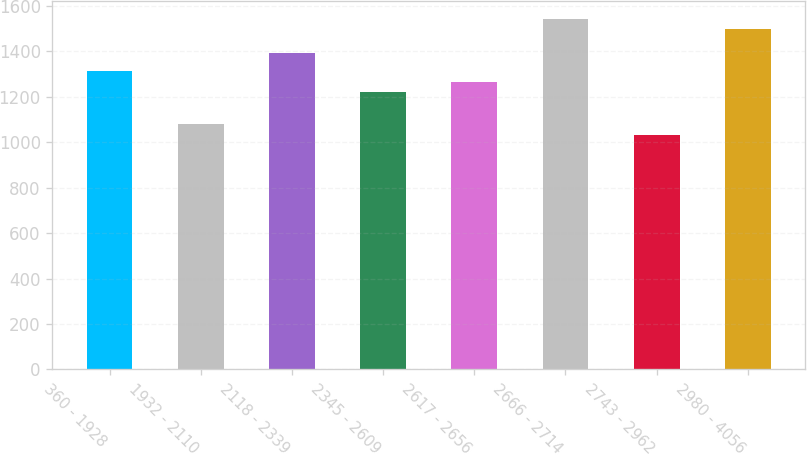Convert chart. <chart><loc_0><loc_0><loc_500><loc_500><bar_chart><fcel>360 - 1928<fcel>1932 - 2110<fcel>2118 - 2339<fcel>2345 - 2609<fcel>2617 - 2656<fcel>2666 - 2714<fcel>2743 - 2962<fcel>2980 - 4056<nl><fcel>1313.4<fcel>1080.2<fcel>1391<fcel>1219<fcel>1266.2<fcel>1542.2<fcel>1033<fcel>1495<nl></chart> 